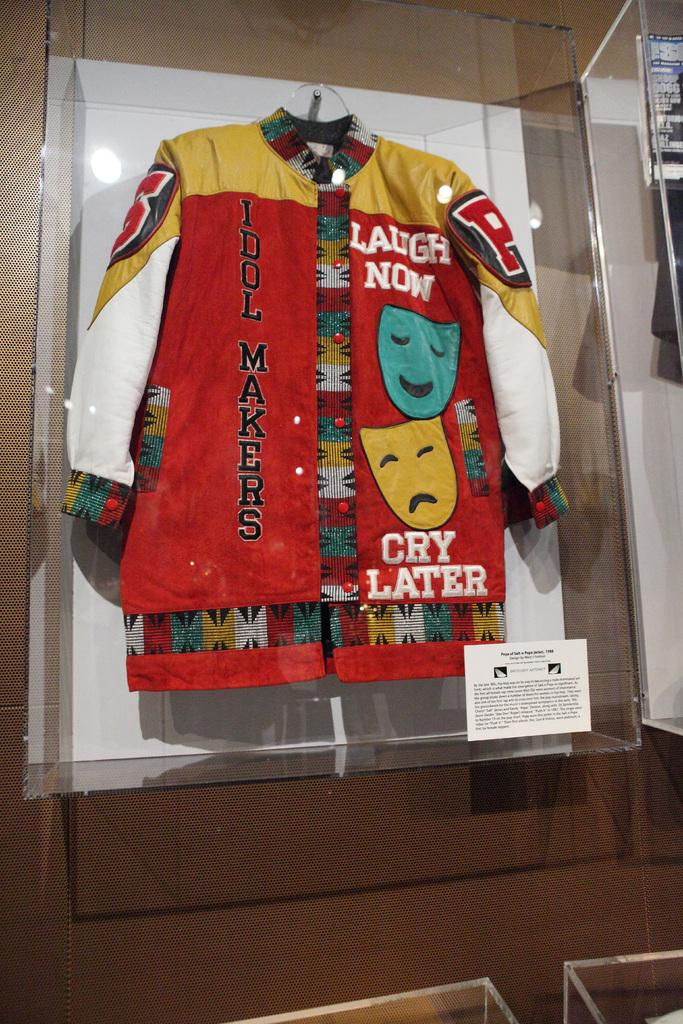Provide a one-sentence caption for the provided image. A red and gold letterman style jacket featuring a smiling and frowing face and the words "laugh now cry later.". 